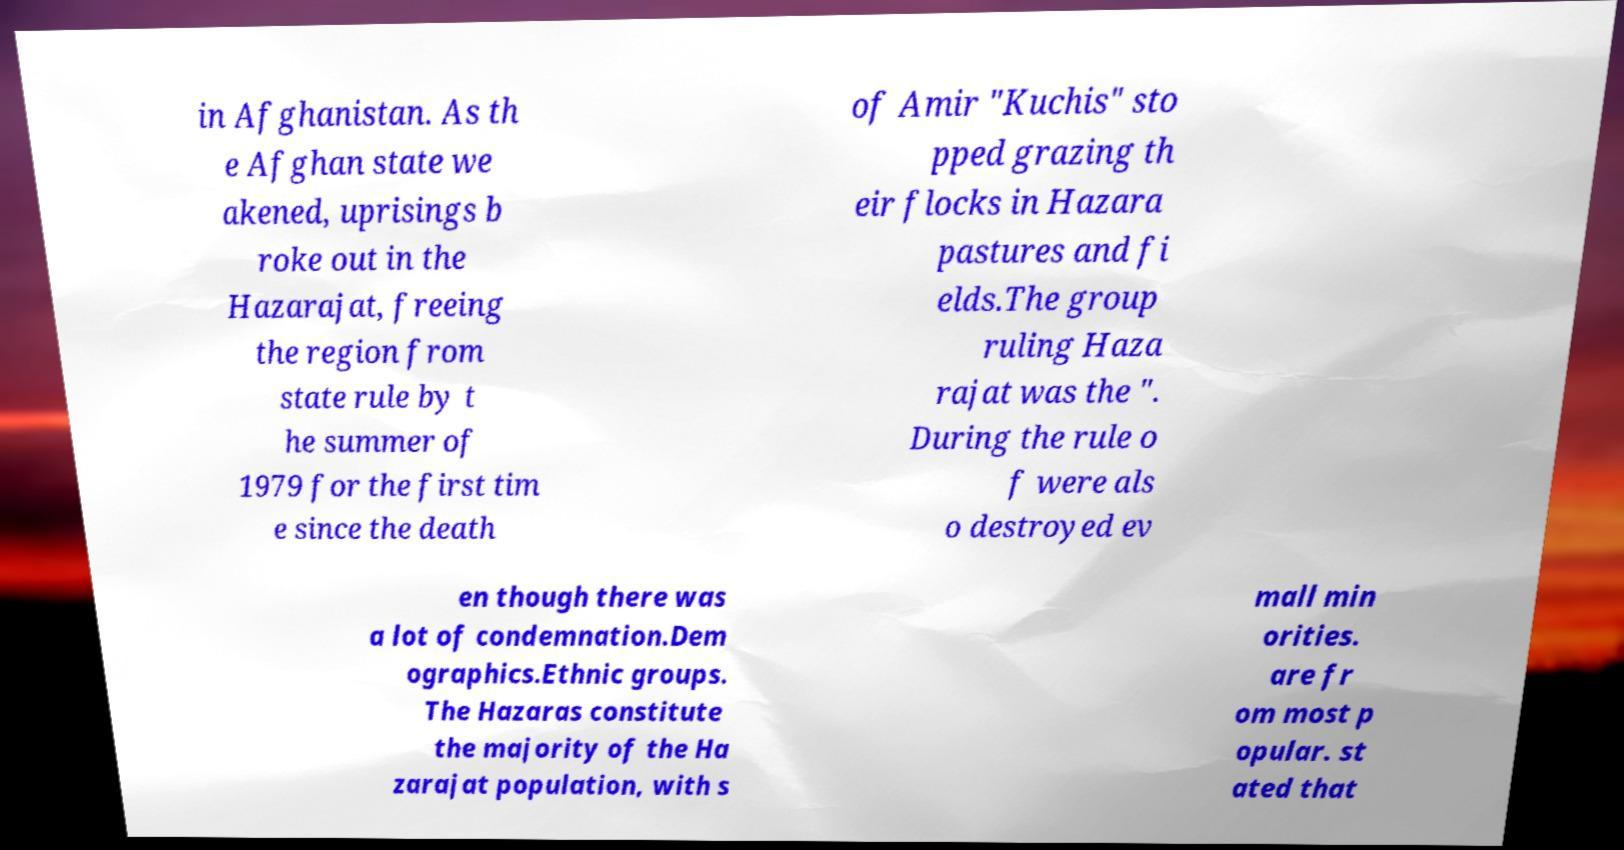Could you extract and type out the text from this image? in Afghanistan. As th e Afghan state we akened, uprisings b roke out in the Hazarajat, freeing the region from state rule by t he summer of 1979 for the first tim e since the death of Amir "Kuchis" sto pped grazing th eir flocks in Hazara pastures and fi elds.The group ruling Haza rajat was the ". During the rule o f were als o destroyed ev en though there was a lot of condemnation.Dem ographics.Ethnic groups. The Hazaras constitute the majority of the Ha zarajat population, with s mall min orities. are fr om most p opular. st ated that 